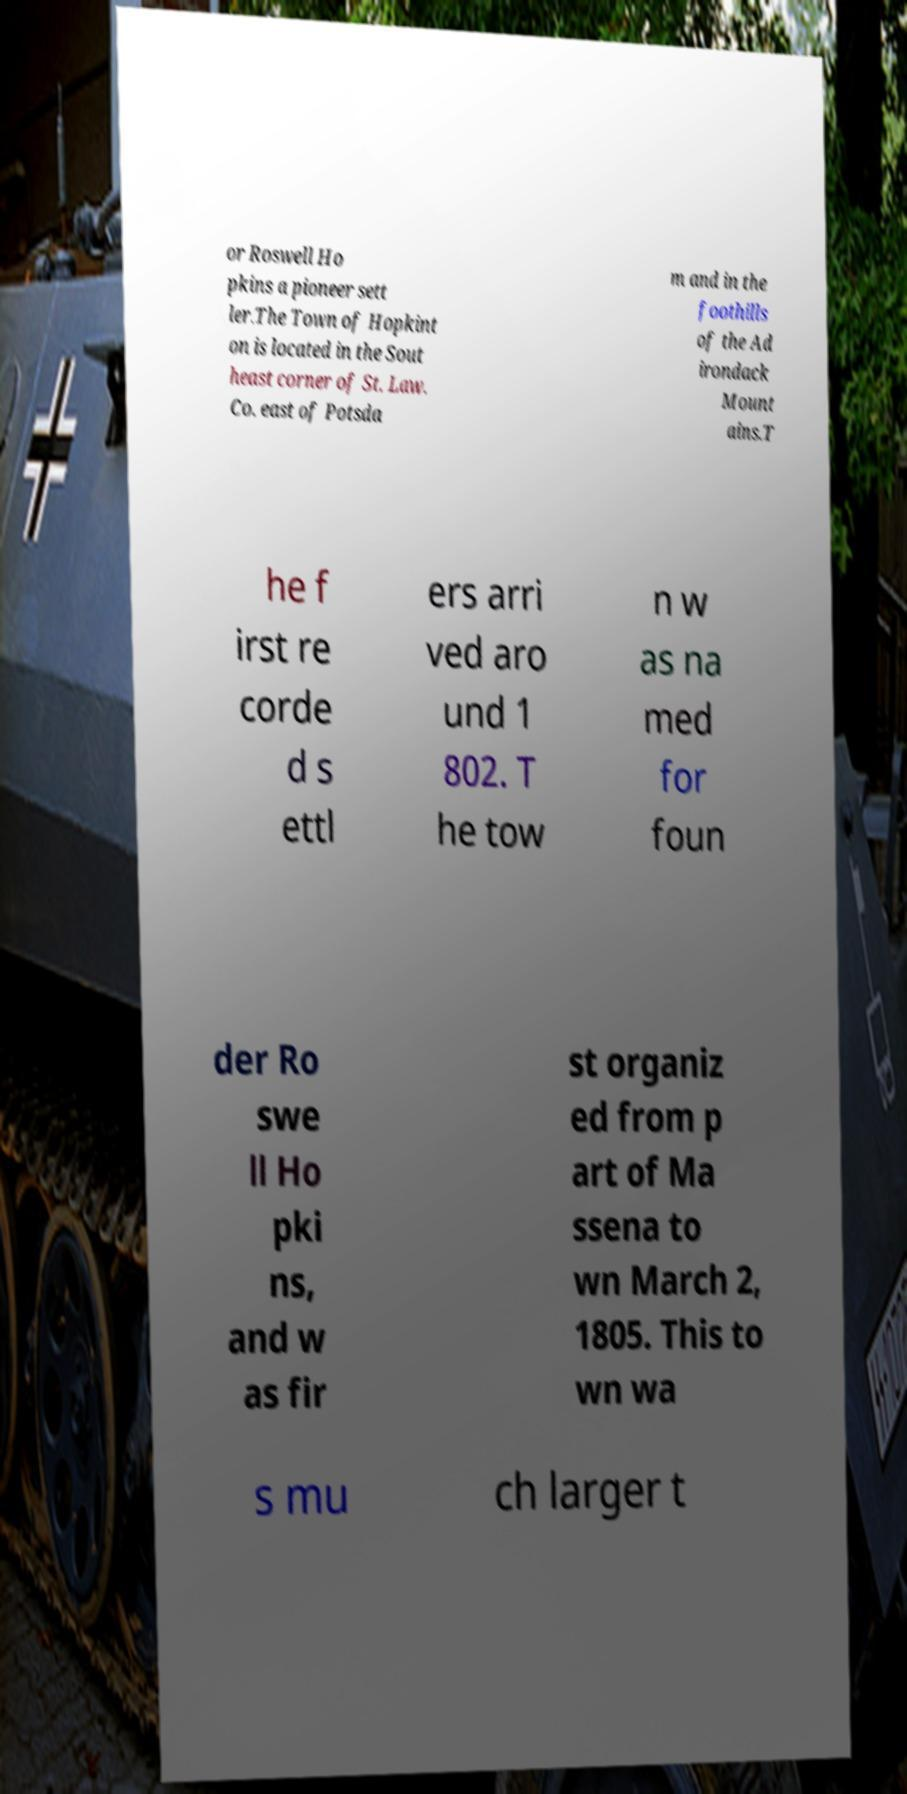Can you accurately transcribe the text from the provided image for me? or Roswell Ho pkins a pioneer sett ler.The Town of Hopkint on is located in the Sout heast corner of St. Law. Co. east of Potsda m and in the foothills of the Ad irondack Mount ains.T he f irst re corde d s ettl ers arri ved aro und 1 802. T he tow n w as na med for foun der Ro swe ll Ho pki ns, and w as fir st organiz ed from p art of Ma ssena to wn March 2, 1805. This to wn wa s mu ch larger t 